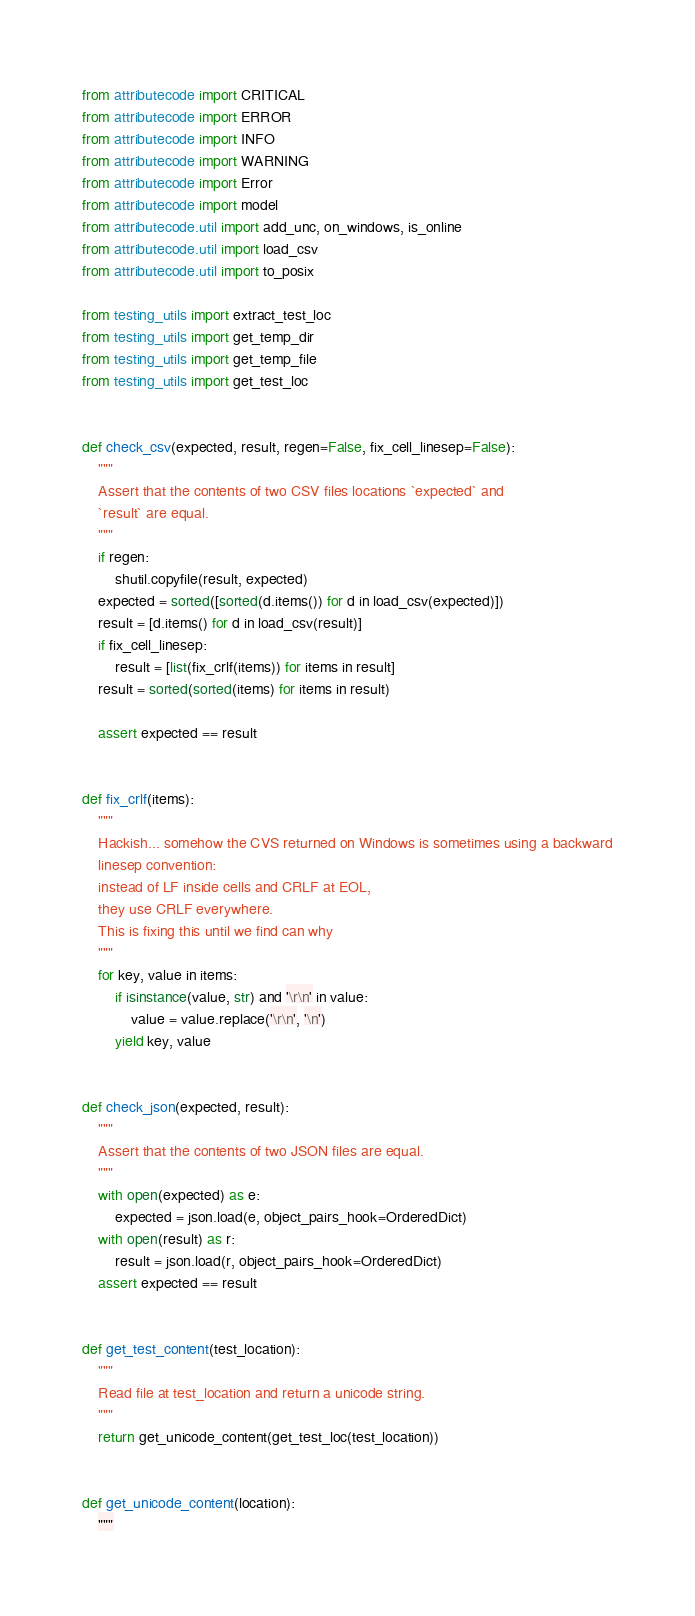<code> <loc_0><loc_0><loc_500><loc_500><_Python_>from attributecode import CRITICAL
from attributecode import ERROR
from attributecode import INFO
from attributecode import WARNING
from attributecode import Error
from attributecode import model
from attributecode.util import add_unc, on_windows, is_online
from attributecode.util import load_csv
from attributecode.util import to_posix

from testing_utils import extract_test_loc
from testing_utils import get_temp_dir
from testing_utils import get_temp_file
from testing_utils import get_test_loc


def check_csv(expected, result, regen=False, fix_cell_linesep=False):
    """
    Assert that the contents of two CSV files locations `expected` and
    `result` are equal.
    """
    if regen:
        shutil.copyfile(result, expected)
    expected = sorted([sorted(d.items()) for d in load_csv(expected)])
    result = [d.items() for d in load_csv(result)]
    if fix_cell_linesep:
        result = [list(fix_crlf(items)) for items in result]
    result = sorted(sorted(items) for items in result)

    assert expected == result


def fix_crlf(items):
    """
    Hackish... somehow the CVS returned on Windows is sometimes using a backward
    linesep convention:
    instead of LF inside cells and CRLF at EOL,
    they use CRLF everywhere.
    This is fixing this until we find can why
    """
    for key, value in items:
        if isinstance(value, str) and '\r\n' in value:
            value = value.replace('\r\n', '\n')
        yield key, value


def check_json(expected, result):
    """
    Assert that the contents of two JSON files are equal.
    """
    with open(expected) as e:
        expected = json.load(e, object_pairs_hook=OrderedDict)
    with open(result) as r:
        result = json.load(r, object_pairs_hook=OrderedDict)
    assert expected == result


def get_test_content(test_location):
    """
    Read file at test_location and return a unicode string.
    """
    return get_unicode_content(get_test_loc(test_location))


def get_unicode_content(location):
    """</code> 